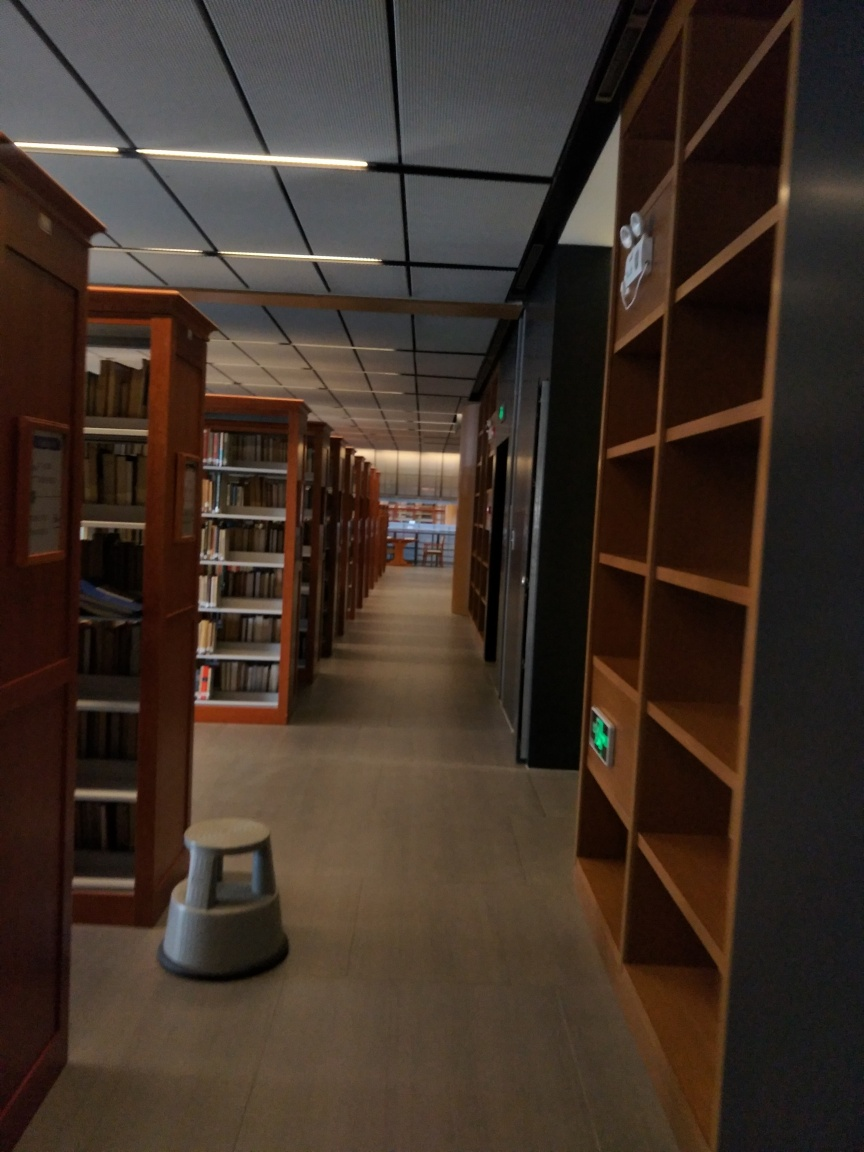Can you describe the lighting conditions in this image? The image depicts a library aisle illuminated by overhead linear lighting fixtures, producing an evenly distributed, artificial light that highlights the corridor and bookshelves. Does the image seem to be taken during a specific time of day? Given the artificial lighting and lack of natural light sources such as windows, it's challenging to determine the specific time of day solely based on the image content. 